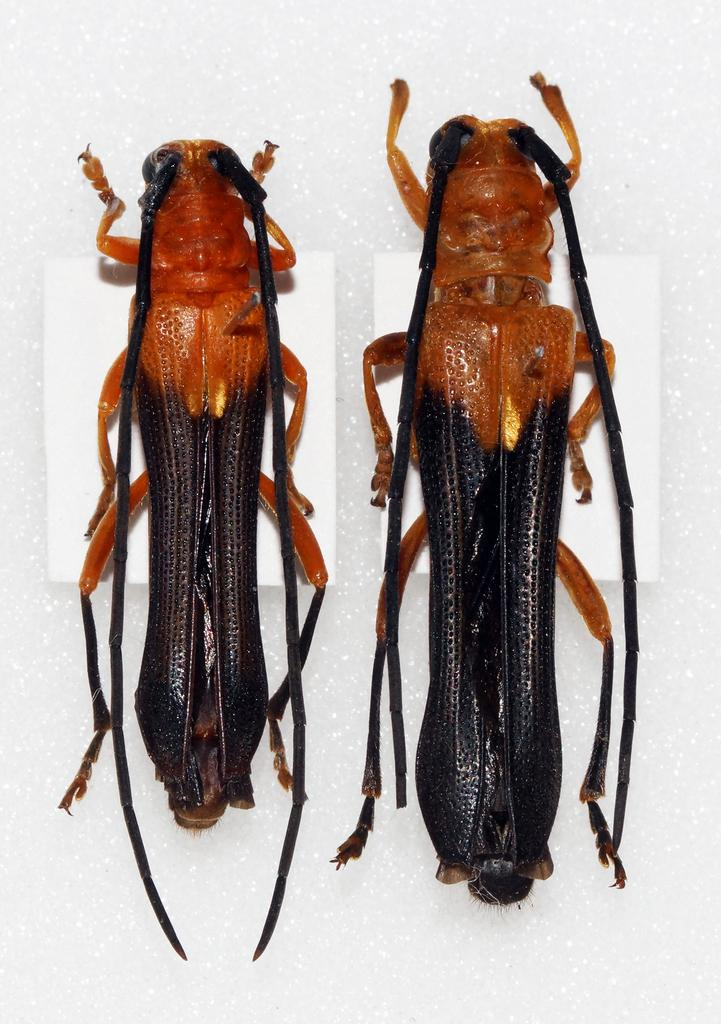What type of creatures can be seen in the image? There are insects in the image. What verse is being recited by the insects in the image? There is no indication in the image that the insects are reciting a verse, as insects do not have the ability to recite poetry. 